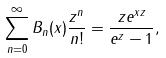<formula> <loc_0><loc_0><loc_500><loc_500>\sum _ { n = 0 } ^ { \infty } B _ { n } ( x ) \frac { z ^ { n } } { n ! } = \frac { z e ^ { x z } } { e ^ { z } - 1 } ,</formula> 